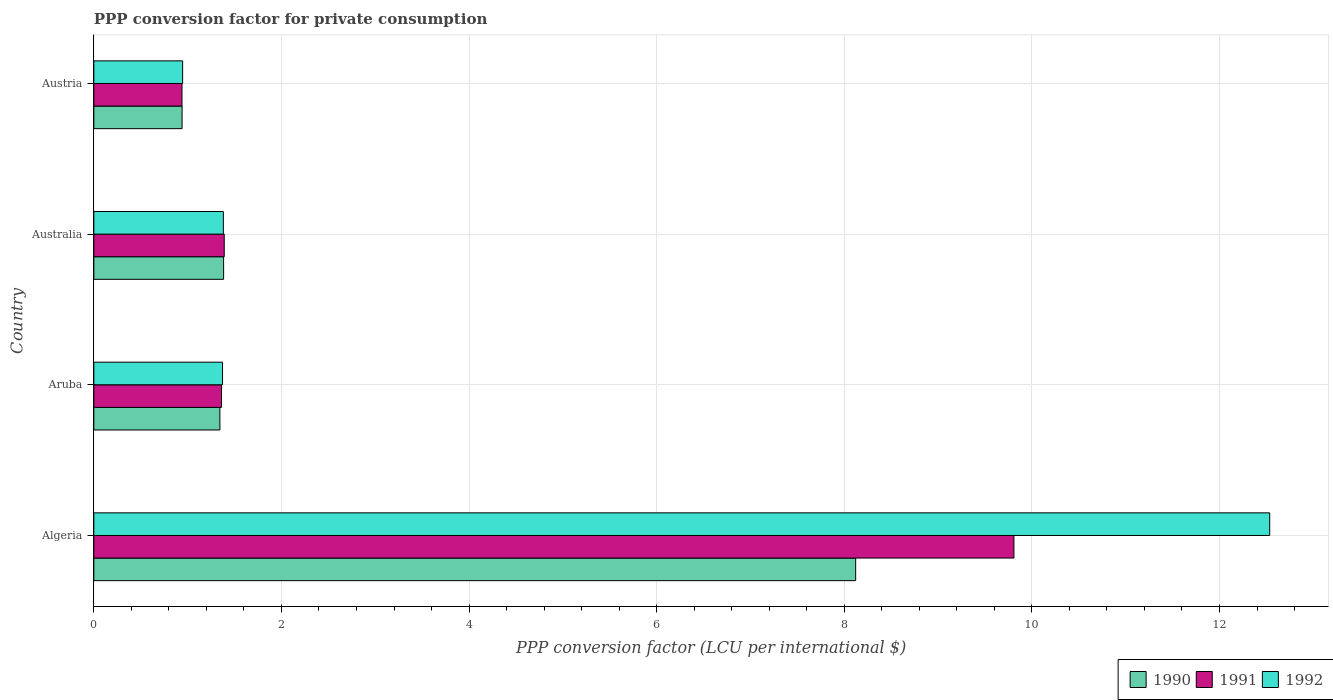How many different coloured bars are there?
Provide a short and direct response. 3. How many groups of bars are there?
Your answer should be very brief. 4. Are the number of bars per tick equal to the number of legend labels?
Your answer should be compact. Yes. What is the label of the 1st group of bars from the top?
Provide a short and direct response. Austria. What is the PPP conversion factor for private consumption in 1991 in Aruba?
Your answer should be very brief. 1.36. Across all countries, what is the maximum PPP conversion factor for private consumption in 1992?
Your answer should be very brief. 12.54. Across all countries, what is the minimum PPP conversion factor for private consumption in 1991?
Ensure brevity in your answer.  0.94. In which country was the PPP conversion factor for private consumption in 1990 maximum?
Your answer should be compact. Algeria. In which country was the PPP conversion factor for private consumption in 1990 minimum?
Your answer should be compact. Austria. What is the total PPP conversion factor for private consumption in 1991 in the graph?
Offer a terse response. 13.5. What is the difference between the PPP conversion factor for private consumption in 1990 in Algeria and that in Austria?
Make the answer very short. 7.18. What is the difference between the PPP conversion factor for private consumption in 1992 in Aruba and the PPP conversion factor for private consumption in 1991 in Austria?
Give a very brief answer. 0.43. What is the average PPP conversion factor for private consumption in 1991 per country?
Your response must be concise. 3.37. What is the difference between the PPP conversion factor for private consumption in 1992 and PPP conversion factor for private consumption in 1991 in Aruba?
Ensure brevity in your answer.  0.01. What is the ratio of the PPP conversion factor for private consumption in 1991 in Aruba to that in Australia?
Your answer should be very brief. 0.98. Is the PPP conversion factor for private consumption in 1992 in Algeria less than that in Austria?
Your answer should be very brief. No. What is the difference between the highest and the second highest PPP conversion factor for private consumption in 1991?
Provide a succinct answer. 8.42. What is the difference between the highest and the lowest PPP conversion factor for private consumption in 1992?
Offer a terse response. 11.59. In how many countries, is the PPP conversion factor for private consumption in 1991 greater than the average PPP conversion factor for private consumption in 1991 taken over all countries?
Your response must be concise. 1. Is the sum of the PPP conversion factor for private consumption in 1991 in Aruba and Austria greater than the maximum PPP conversion factor for private consumption in 1992 across all countries?
Ensure brevity in your answer.  No. Is it the case that in every country, the sum of the PPP conversion factor for private consumption in 1991 and PPP conversion factor for private consumption in 1992 is greater than the PPP conversion factor for private consumption in 1990?
Give a very brief answer. Yes. What is the difference between two consecutive major ticks on the X-axis?
Offer a very short reply. 2. Are the values on the major ticks of X-axis written in scientific E-notation?
Your answer should be compact. No. Does the graph contain grids?
Provide a short and direct response. Yes. How many legend labels are there?
Provide a short and direct response. 3. How are the legend labels stacked?
Provide a succinct answer. Horizontal. What is the title of the graph?
Make the answer very short. PPP conversion factor for private consumption. What is the label or title of the X-axis?
Keep it short and to the point. PPP conversion factor (LCU per international $). What is the label or title of the Y-axis?
Offer a terse response. Country. What is the PPP conversion factor (LCU per international $) in 1990 in Algeria?
Ensure brevity in your answer.  8.12. What is the PPP conversion factor (LCU per international $) in 1991 in Algeria?
Make the answer very short. 9.81. What is the PPP conversion factor (LCU per international $) of 1992 in Algeria?
Give a very brief answer. 12.54. What is the PPP conversion factor (LCU per international $) in 1990 in Aruba?
Your answer should be very brief. 1.34. What is the PPP conversion factor (LCU per international $) in 1991 in Aruba?
Your answer should be very brief. 1.36. What is the PPP conversion factor (LCU per international $) of 1992 in Aruba?
Provide a succinct answer. 1.37. What is the PPP conversion factor (LCU per international $) in 1990 in Australia?
Ensure brevity in your answer.  1.38. What is the PPP conversion factor (LCU per international $) in 1991 in Australia?
Keep it short and to the point. 1.39. What is the PPP conversion factor (LCU per international $) in 1992 in Australia?
Keep it short and to the point. 1.38. What is the PPP conversion factor (LCU per international $) in 1990 in Austria?
Offer a terse response. 0.94. What is the PPP conversion factor (LCU per international $) of 1991 in Austria?
Your response must be concise. 0.94. What is the PPP conversion factor (LCU per international $) in 1992 in Austria?
Offer a very short reply. 0.95. Across all countries, what is the maximum PPP conversion factor (LCU per international $) of 1990?
Provide a short and direct response. 8.12. Across all countries, what is the maximum PPP conversion factor (LCU per international $) in 1991?
Offer a very short reply. 9.81. Across all countries, what is the maximum PPP conversion factor (LCU per international $) in 1992?
Offer a terse response. 12.54. Across all countries, what is the minimum PPP conversion factor (LCU per international $) of 1990?
Provide a short and direct response. 0.94. Across all countries, what is the minimum PPP conversion factor (LCU per international $) in 1991?
Provide a short and direct response. 0.94. Across all countries, what is the minimum PPP conversion factor (LCU per international $) of 1992?
Offer a very short reply. 0.95. What is the total PPP conversion factor (LCU per international $) of 1990 in the graph?
Keep it short and to the point. 11.79. What is the total PPP conversion factor (LCU per international $) in 1991 in the graph?
Offer a terse response. 13.5. What is the total PPP conversion factor (LCU per international $) in 1992 in the graph?
Offer a very short reply. 16.23. What is the difference between the PPP conversion factor (LCU per international $) of 1990 in Algeria and that in Aruba?
Provide a succinct answer. 6.78. What is the difference between the PPP conversion factor (LCU per international $) in 1991 in Algeria and that in Aruba?
Ensure brevity in your answer.  8.45. What is the difference between the PPP conversion factor (LCU per international $) in 1992 in Algeria and that in Aruba?
Make the answer very short. 11.16. What is the difference between the PPP conversion factor (LCU per international $) of 1990 in Algeria and that in Australia?
Provide a succinct answer. 6.74. What is the difference between the PPP conversion factor (LCU per international $) of 1991 in Algeria and that in Australia?
Offer a very short reply. 8.42. What is the difference between the PPP conversion factor (LCU per international $) in 1992 in Algeria and that in Australia?
Your answer should be compact. 11.15. What is the difference between the PPP conversion factor (LCU per international $) of 1990 in Algeria and that in Austria?
Offer a terse response. 7.18. What is the difference between the PPP conversion factor (LCU per international $) in 1991 in Algeria and that in Austria?
Ensure brevity in your answer.  8.87. What is the difference between the PPP conversion factor (LCU per international $) in 1992 in Algeria and that in Austria?
Provide a short and direct response. 11.59. What is the difference between the PPP conversion factor (LCU per international $) in 1990 in Aruba and that in Australia?
Give a very brief answer. -0.04. What is the difference between the PPP conversion factor (LCU per international $) of 1991 in Aruba and that in Australia?
Keep it short and to the point. -0.03. What is the difference between the PPP conversion factor (LCU per international $) of 1992 in Aruba and that in Australia?
Offer a terse response. -0.01. What is the difference between the PPP conversion factor (LCU per international $) of 1990 in Aruba and that in Austria?
Give a very brief answer. 0.4. What is the difference between the PPP conversion factor (LCU per international $) in 1991 in Aruba and that in Austria?
Your answer should be very brief. 0.42. What is the difference between the PPP conversion factor (LCU per international $) in 1992 in Aruba and that in Austria?
Offer a very short reply. 0.43. What is the difference between the PPP conversion factor (LCU per international $) of 1990 in Australia and that in Austria?
Offer a very short reply. 0.44. What is the difference between the PPP conversion factor (LCU per international $) in 1991 in Australia and that in Austria?
Your answer should be very brief. 0.45. What is the difference between the PPP conversion factor (LCU per international $) of 1992 in Australia and that in Austria?
Offer a very short reply. 0.43. What is the difference between the PPP conversion factor (LCU per international $) of 1990 in Algeria and the PPP conversion factor (LCU per international $) of 1991 in Aruba?
Offer a terse response. 6.76. What is the difference between the PPP conversion factor (LCU per international $) of 1990 in Algeria and the PPP conversion factor (LCU per international $) of 1992 in Aruba?
Keep it short and to the point. 6.75. What is the difference between the PPP conversion factor (LCU per international $) in 1991 in Algeria and the PPP conversion factor (LCU per international $) in 1992 in Aruba?
Ensure brevity in your answer.  8.44. What is the difference between the PPP conversion factor (LCU per international $) in 1990 in Algeria and the PPP conversion factor (LCU per international $) in 1991 in Australia?
Your answer should be compact. 6.73. What is the difference between the PPP conversion factor (LCU per international $) in 1990 in Algeria and the PPP conversion factor (LCU per international $) in 1992 in Australia?
Provide a succinct answer. 6.74. What is the difference between the PPP conversion factor (LCU per international $) of 1991 in Algeria and the PPP conversion factor (LCU per international $) of 1992 in Australia?
Provide a short and direct response. 8.43. What is the difference between the PPP conversion factor (LCU per international $) of 1990 in Algeria and the PPP conversion factor (LCU per international $) of 1991 in Austria?
Keep it short and to the point. 7.18. What is the difference between the PPP conversion factor (LCU per international $) of 1990 in Algeria and the PPP conversion factor (LCU per international $) of 1992 in Austria?
Your response must be concise. 7.17. What is the difference between the PPP conversion factor (LCU per international $) of 1991 in Algeria and the PPP conversion factor (LCU per international $) of 1992 in Austria?
Offer a very short reply. 8.86. What is the difference between the PPP conversion factor (LCU per international $) in 1990 in Aruba and the PPP conversion factor (LCU per international $) in 1991 in Australia?
Provide a succinct answer. -0.05. What is the difference between the PPP conversion factor (LCU per international $) of 1990 in Aruba and the PPP conversion factor (LCU per international $) of 1992 in Australia?
Your answer should be compact. -0.04. What is the difference between the PPP conversion factor (LCU per international $) of 1991 in Aruba and the PPP conversion factor (LCU per international $) of 1992 in Australia?
Your answer should be very brief. -0.02. What is the difference between the PPP conversion factor (LCU per international $) in 1990 in Aruba and the PPP conversion factor (LCU per international $) in 1991 in Austria?
Offer a very short reply. 0.4. What is the difference between the PPP conversion factor (LCU per international $) in 1990 in Aruba and the PPP conversion factor (LCU per international $) in 1992 in Austria?
Your answer should be compact. 0.4. What is the difference between the PPP conversion factor (LCU per international $) of 1991 in Aruba and the PPP conversion factor (LCU per international $) of 1992 in Austria?
Provide a short and direct response. 0.41. What is the difference between the PPP conversion factor (LCU per international $) of 1990 in Australia and the PPP conversion factor (LCU per international $) of 1991 in Austria?
Your answer should be very brief. 0.44. What is the difference between the PPP conversion factor (LCU per international $) of 1990 in Australia and the PPP conversion factor (LCU per international $) of 1992 in Austria?
Offer a very short reply. 0.44. What is the difference between the PPP conversion factor (LCU per international $) in 1991 in Australia and the PPP conversion factor (LCU per international $) in 1992 in Austria?
Keep it short and to the point. 0.44. What is the average PPP conversion factor (LCU per international $) in 1990 per country?
Your response must be concise. 2.95. What is the average PPP conversion factor (LCU per international $) in 1991 per country?
Your answer should be very brief. 3.37. What is the average PPP conversion factor (LCU per international $) of 1992 per country?
Ensure brevity in your answer.  4.06. What is the difference between the PPP conversion factor (LCU per international $) of 1990 and PPP conversion factor (LCU per international $) of 1991 in Algeria?
Keep it short and to the point. -1.69. What is the difference between the PPP conversion factor (LCU per international $) of 1990 and PPP conversion factor (LCU per international $) of 1992 in Algeria?
Your answer should be very brief. -4.41. What is the difference between the PPP conversion factor (LCU per international $) in 1991 and PPP conversion factor (LCU per international $) in 1992 in Algeria?
Ensure brevity in your answer.  -2.73. What is the difference between the PPP conversion factor (LCU per international $) in 1990 and PPP conversion factor (LCU per international $) in 1991 in Aruba?
Your answer should be compact. -0.02. What is the difference between the PPP conversion factor (LCU per international $) in 1990 and PPP conversion factor (LCU per international $) in 1992 in Aruba?
Offer a terse response. -0.03. What is the difference between the PPP conversion factor (LCU per international $) in 1991 and PPP conversion factor (LCU per international $) in 1992 in Aruba?
Give a very brief answer. -0.01. What is the difference between the PPP conversion factor (LCU per international $) of 1990 and PPP conversion factor (LCU per international $) of 1991 in Australia?
Provide a succinct answer. -0.01. What is the difference between the PPP conversion factor (LCU per international $) of 1990 and PPP conversion factor (LCU per international $) of 1992 in Australia?
Make the answer very short. 0. What is the difference between the PPP conversion factor (LCU per international $) of 1991 and PPP conversion factor (LCU per international $) of 1992 in Australia?
Your answer should be very brief. 0.01. What is the difference between the PPP conversion factor (LCU per international $) of 1990 and PPP conversion factor (LCU per international $) of 1991 in Austria?
Your response must be concise. 0. What is the difference between the PPP conversion factor (LCU per international $) of 1990 and PPP conversion factor (LCU per international $) of 1992 in Austria?
Provide a succinct answer. -0.01. What is the difference between the PPP conversion factor (LCU per international $) of 1991 and PPP conversion factor (LCU per international $) of 1992 in Austria?
Your answer should be very brief. -0.01. What is the ratio of the PPP conversion factor (LCU per international $) in 1990 in Algeria to that in Aruba?
Give a very brief answer. 6.04. What is the ratio of the PPP conversion factor (LCU per international $) in 1991 in Algeria to that in Aruba?
Your answer should be compact. 7.21. What is the ratio of the PPP conversion factor (LCU per international $) of 1992 in Algeria to that in Aruba?
Your response must be concise. 9.14. What is the ratio of the PPP conversion factor (LCU per international $) of 1990 in Algeria to that in Australia?
Your response must be concise. 5.87. What is the ratio of the PPP conversion factor (LCU per international $) in 1991 in Algeria to that in Australia?
Your answer should be very brief. 7.06. What is the ratio of the PPP conversion factor (LCU per international $) in 1992 in Algeria to that in Australia?
Offer a very short reply. 9.08. What is the ratio of the PPP conversion factor (LCU per international $) in 1990 in Algeria to that in Austria?
Provide a short and direct response. 8.63. What is the ratio of the PPP conversion factor (LCU per international $) in 1991 in Algeria to that in Austria?
Give a very brief answer. 10.43. What is the ratio of the PPP conversion factor (LCU per international $) of 1992 in Algeria to that in Austria?
Offer a very short reply. 13.24. What is the ratio of the PPP conversion factor (LCU per international $) of 1990 in Aruba to that in Australia?
Your answer should be very brief. 0.97. What is the ratio of the PPP conversion factor (LCU per international $) of 1992 in Aruba to that in Australia?
Provide a succinct answer. 0.99. What is the ratio of the PPP conversion factor (LCU per international $) of 1990 in Aruba to that in Austria?
Keep it short and to the point. 1.43. What is the ratio of the PPP conversion factor (LCU per international $) in 1991 in Aruba to that in Austria?
Provide a succinct answer. 1.45. What is the ratio of the PPP conversion factor (LCU per international $) in 1992 in Aruba to that in Austria?
Ensure brevity in your answer.  1.45. What is the ratio of the PPP conversion factor (LCU per international $) in 1990 in Australia to that in Austria?
Give a very brief answer. 1.47. What is the ratio of the PPP conversion factor (LCU per international $) of 1991 in Australia to that in Austria?
Offer a very short reply. 1.48. What is the ratio of the PPP conversion factor (LCU per international $) of 1992 in Australia to that in Austria?
Make the answer very short. 1.46. What is the difference between the highest and the second highest PPP conversion factor (LCU per international $) in 1990?
Your answer should be very brief. 6.74. What is the difference between the highest and the second highest PPP conversion factor (LCU per international $) in 1991?
Your answer should be very brief. 8.42. What is the difference between the highest and the second highest PPP conversion factor (LCU per international $) of 1992?
Offer a very short reply. 11.15. What is the difference between the highest and the lowest PPP conversion factor (LCU per international $) of 1990?
Offer a terse response. 7.18. What is the difference between the highest and the lowest PPP conversion factor (LCU per international $) in 1991?
Your answer should be compact. 8.87. What is the difference between the highest and the lowest PPP conversion factor (LCU per international $) in 1992?
Your answer should be compact. 11.59. 